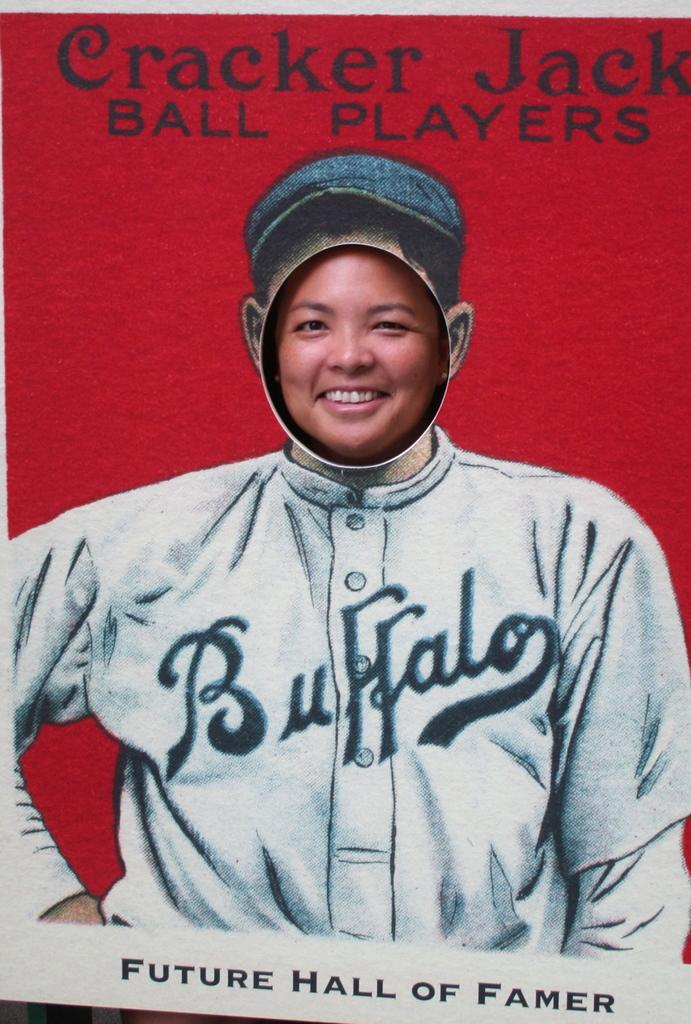<image>
Summarize the visual content of the image. A woman stands behind a Cracker Jack Ball Players board 